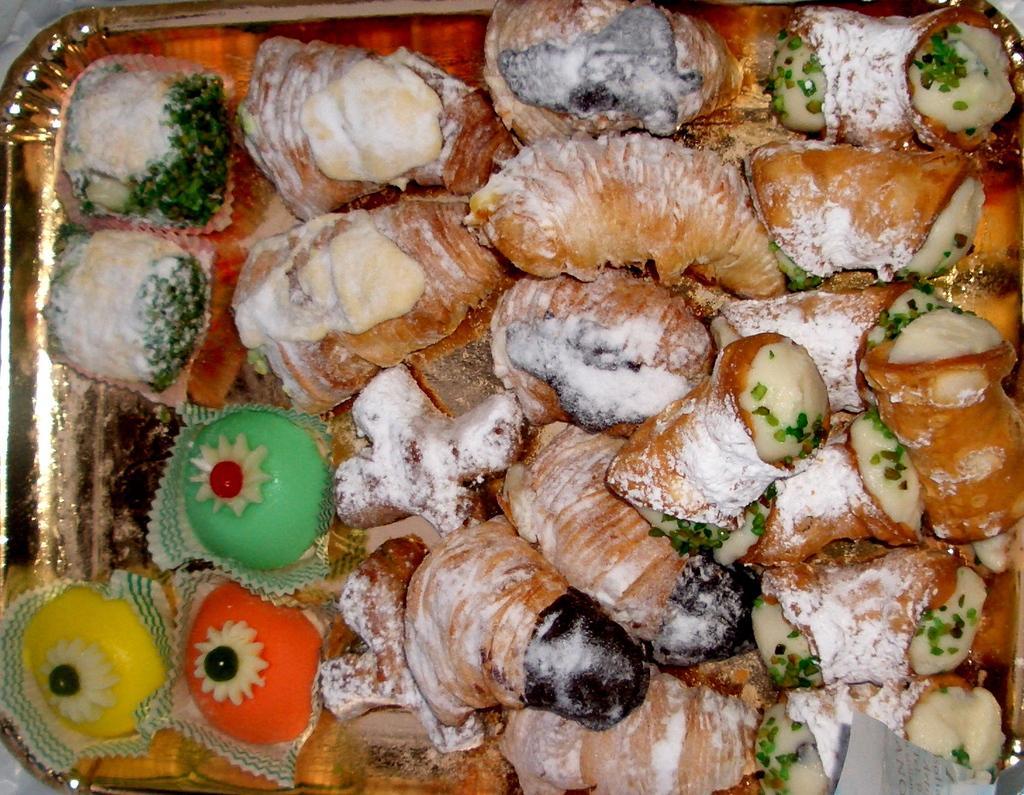In one or two sentences, can you explain what this image depicts? In this image, I can see croissants, sweets and some other food items are placed on the tray. This tray is gold in color. 